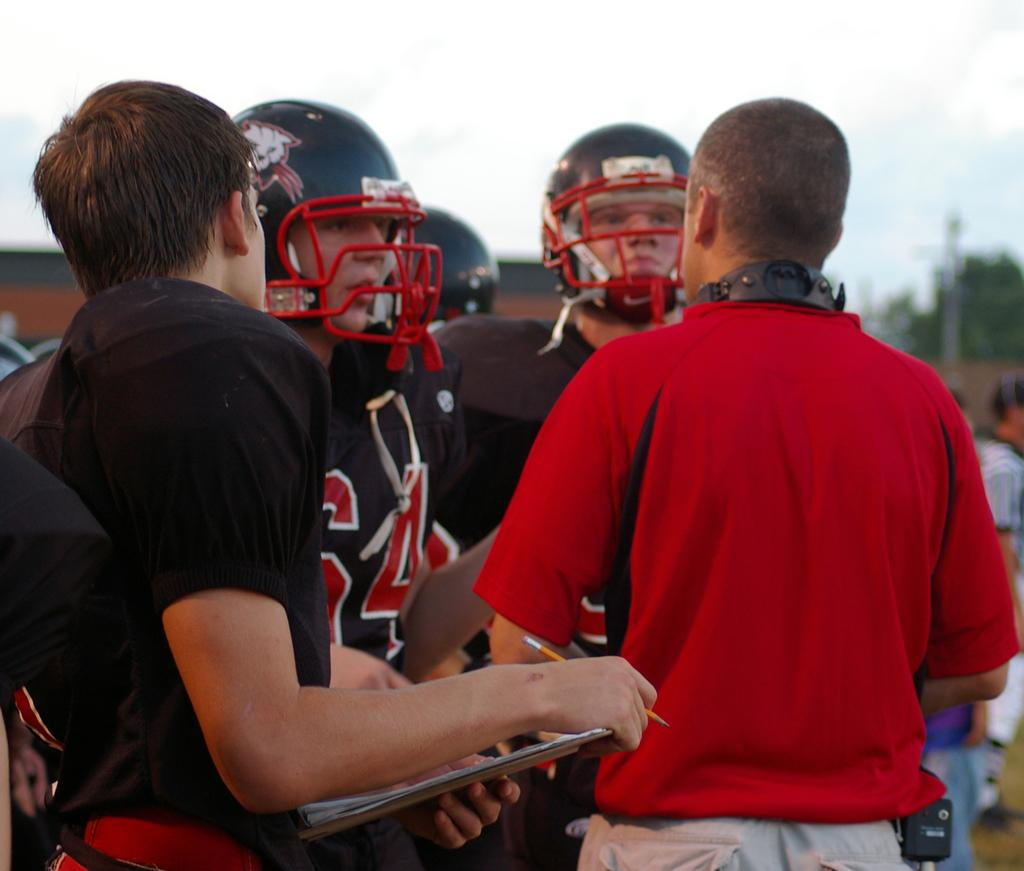How many people are in the image? There are people in the image, but the exact number is not specified. What are some people wearing in the image? Some people are wearing helmets in the image. What can be seen in the background of the image? There are trees and buildings visible in the background of the image. What type of marble is being used to construct the buildings in the image? There is no mention of marble or any construction materials in the image. The buildings are simply visible in the background. What type of wool is being worn by the people in the image? There is no mention of wool or any specific clothing materials in the image. The fact only mentions that some people are wearing helmets. 